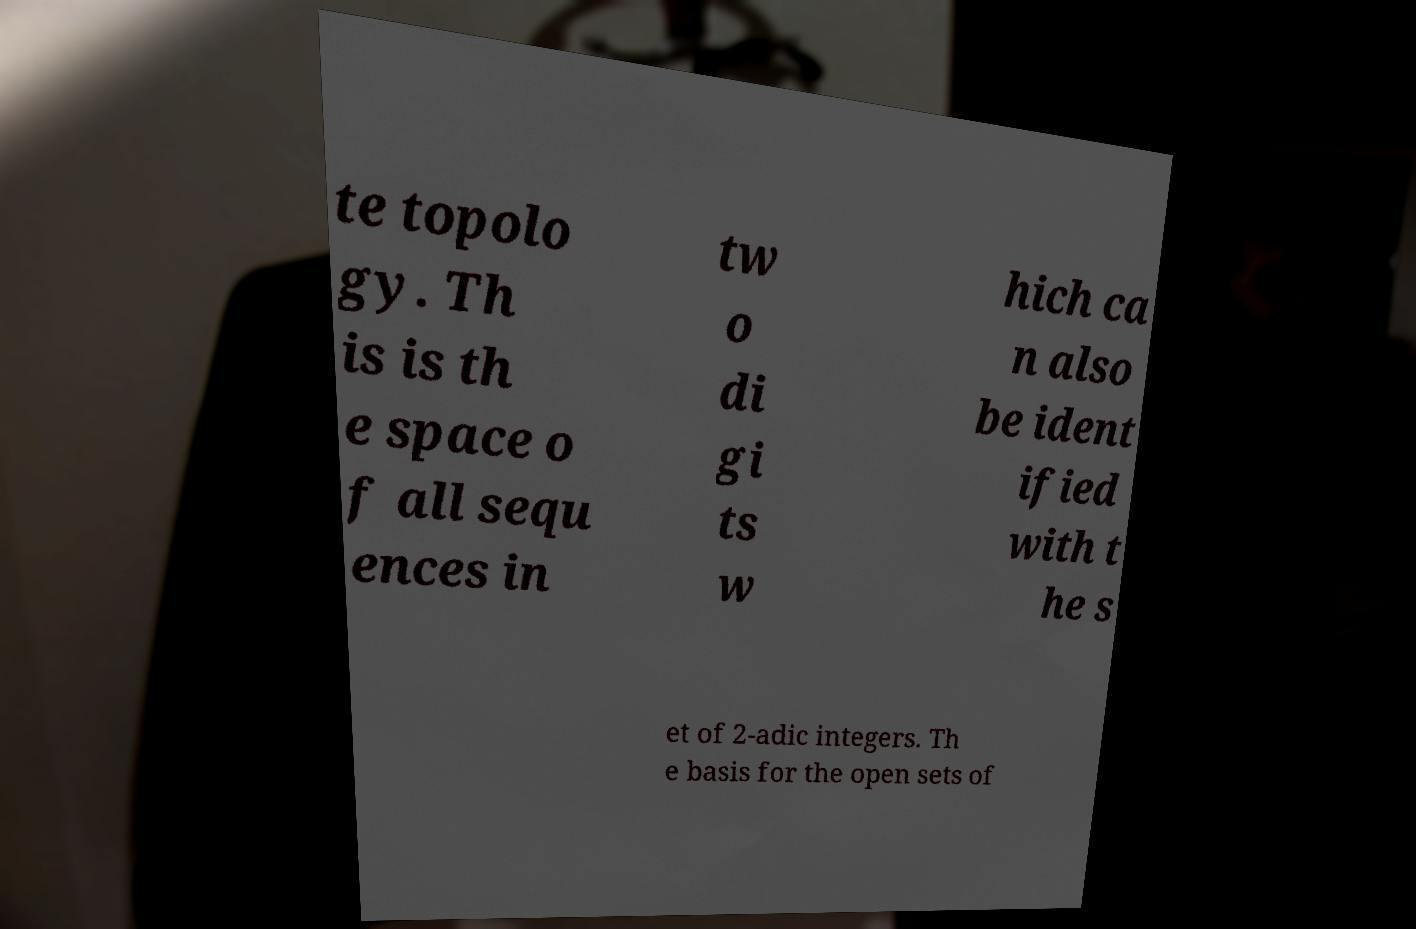There's text embedded in this image that I need extracted. Can you transcribe it verbatim? te topolo gy. Th is is th e space o f all sequ ences in tw o di gi ts w hich ca n also be ident ified with t he s et of 2-adic integers. Th e basis for the open sets of 